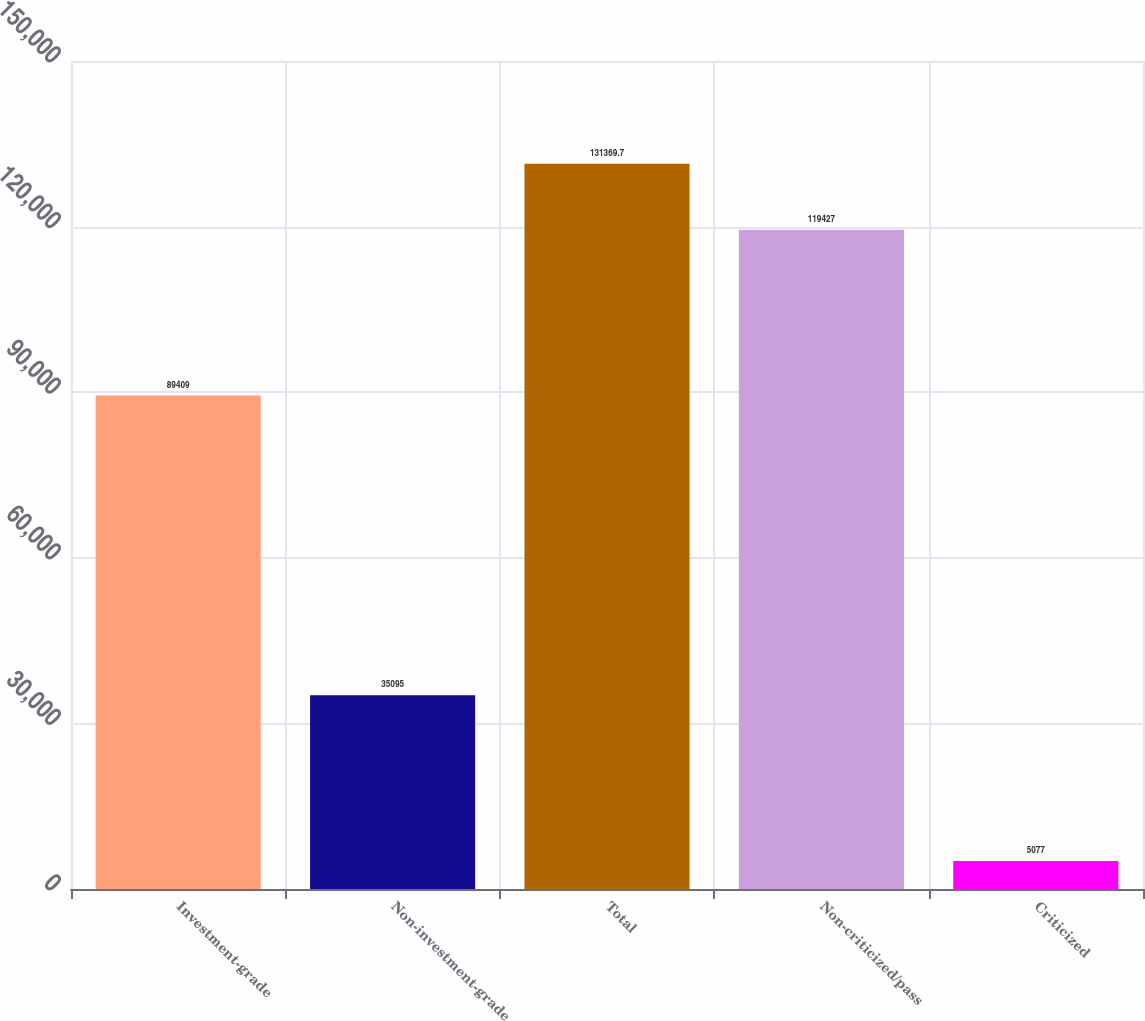<chart> <loc_0><loc_0><loc_500><loc_500><bar_chart><fcel>Investment-grade<fcel>Non-investment-grade<fcel>Total<fcel>Non-criticized/pass<fcel>Criticized<nl><fcel>89409<fcel>35095<fcel>131370<fcel>119427<fcel>5077<nl></chart> 